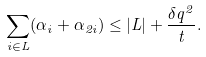Convert formula to latex. <formula><loc_0><loc_0><loc_500><loc_500>\sum _ { i \in L } ( \alpha _ { i } + \alpha _ { 2 i } ) \leq | L | + \frac { \delta q ^ { 2 } } { t } .</formula> 